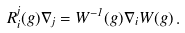Convert formula to latex. <formula><loc_0><loc_0><loc_500><loc_500>R _ { i } ^ { j } ( g ) \nabla _ { j } = W ^ { - 1 } ( g ) \nabla _ { i } W ( g ) \, .</formula> 